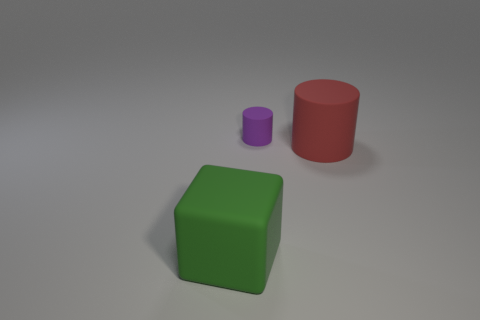There is a object that is on the right side of the large green rubber block and in front of the small object; what is its color?
Offer a very short reply. Red. The red object that is the same size as the green matte thing is what shape?
Make the answer very short. Cylinder. Are there the same number of matte things that are to the left of the big green block and green rubber cylinders?
Your response must be concise. Yes. There is a object that is in front of the tiny thing and right of the big cube; what is its size?
Offer a very short reply. Large. The other large cylinder that is the same material as the purple cylinder is what color?
Offer a very short reply. Red. What number of small things have the same material as the small cylinder?
Provide a succinct answer. 0. Is the number of tiny purple things that are in front of the big matte cylinder the same as the number of rubber cylinders that are left of the tiny object?
Make the answer very short. Yes. Does the green object have the same shape as the object that is behind the red cylinder?
Provide a succinct answer. No. Is there anything else that has the same shape as the large green object?
Your response must be concise. No. There is a big matte object that is behind the large rubber thing that is on the left side of the big thing that is to the right of the green cube; what is its color?
Offer a very short reply. Red. 